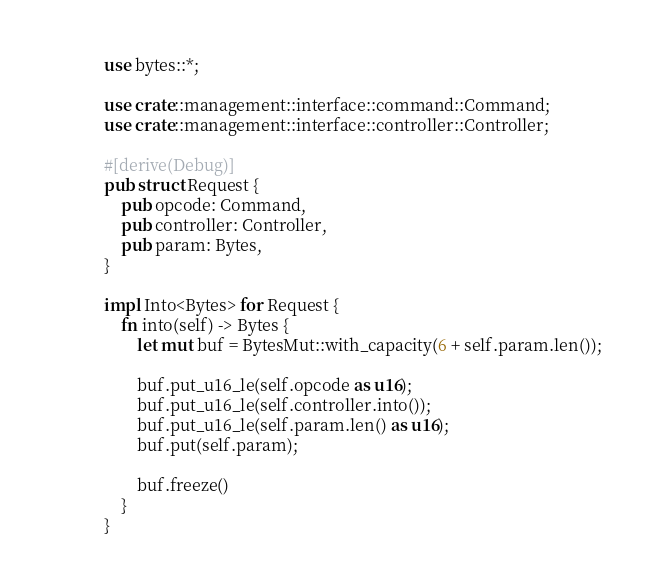Convert code to text. <code><loc_0><loc_0><loc_500><loc_500><_Rust_>use bytes::*;

use crate::management::interface::command::Command;
use crate::management::interface::controller::Controller;

#[derive(Debug)]
pub struct Request {
    pub opcode: Command,
    pub controller: Controller,
    pub param: Bytes,
}

impl Into<Bytes> for Request {
    fn into(self) -> Bytes {
        let mut buf = BytesMut::with_capacity(6 + self.param.len());

        buf.put_u16_le(self.opcode as u16);
        buf.put_u16_le(self.controller.into());
        buf.put_u16_le(self.param.len() as u16);
        buf.put(self.param);

        buf.freeze()
    }
}
</code> 